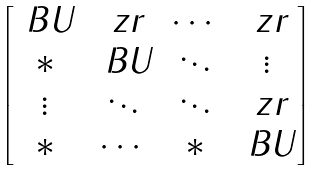Convert formula to latex. <formula><loc_0><loc_0><loc_500><loc_500>\begin{bmatrix} \ B U & \ z r & \cdots & \ z r \\ * & \ B U & \ddots & \vdots \\ \vdots & \ddots & \ddots & \ z r \\ * & \cdots & * & \ B U \end{bmatrix}</formula> 